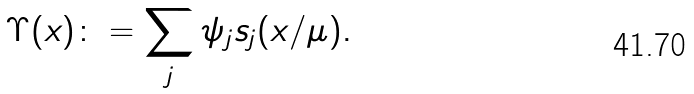Convert formula to latex. <formula><loc_0><loc_0><loc_500><loc_500>\Upsilon ( x ) \colon = \sum _ { j } \psi _ { j } s _ { j } ( x / \mu ) .</formula> 